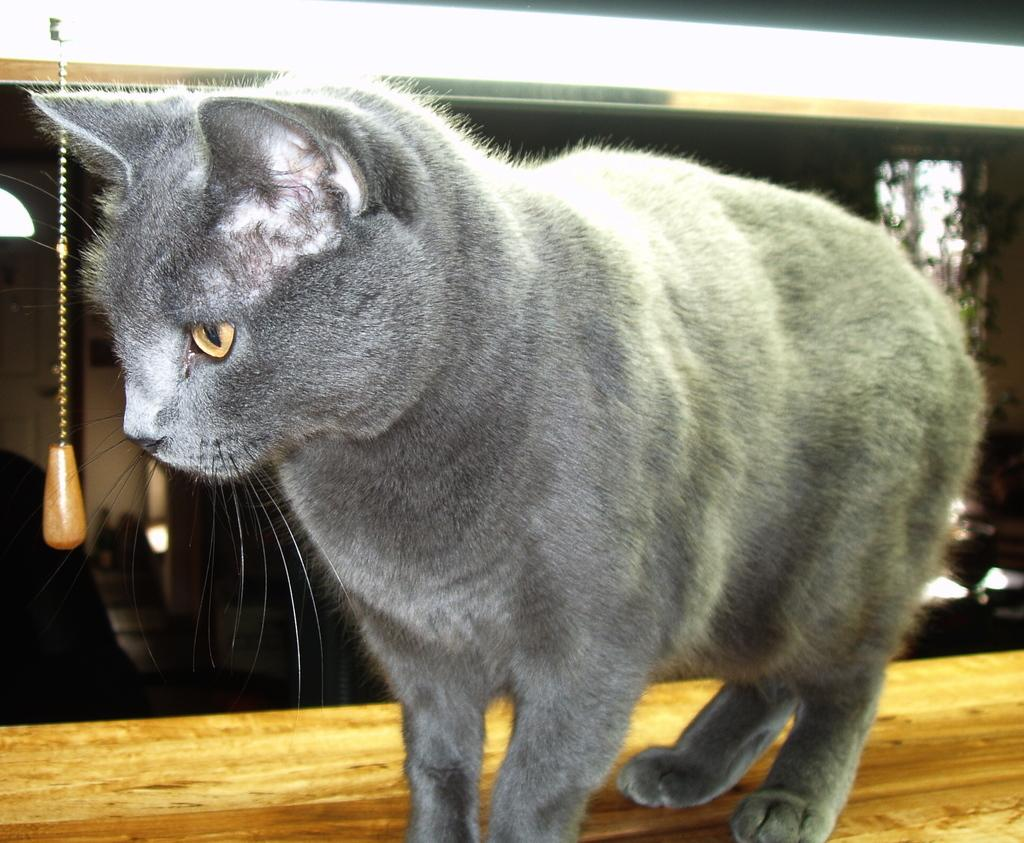What type of animal is in the image? There is a grey color cat in the image. What is the cat sitting on? The cat is on a wooden surface. Can you describe the lighting in the image? There is a light at the top of the image. What type of metal is the cat using to express approval in the image? There is no metal or expression of approval present in the image; it features a grey color cat on a wooden surface with a light at the top. 